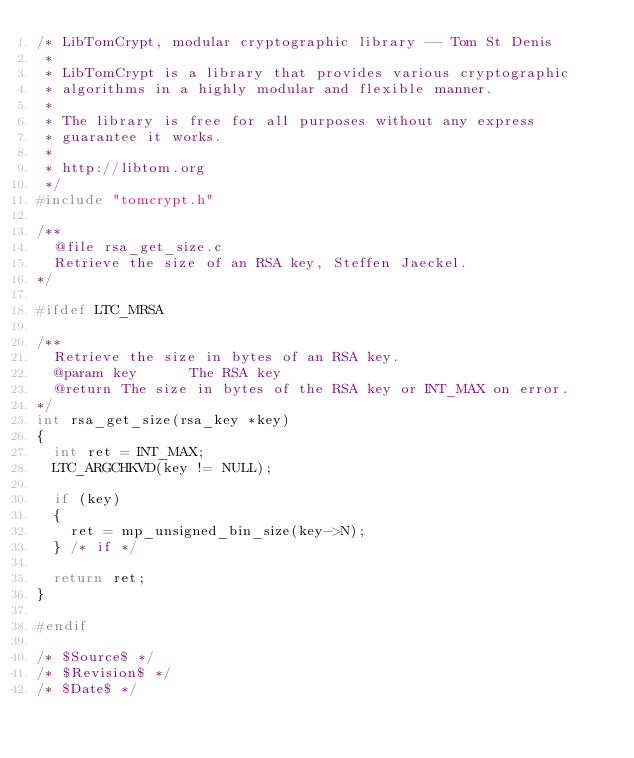Convert code to text. <code><loc_0><loc_0><loc_500><loc_500><_C_>/* LibTomCrypt, modular cryptographic library -- Tom St Denis
 *
 * LibTomCrypt is a library that provides various cryptographic
 * algorithms in a highly modular and flexible manner.
 *
 * The library is free for all purposes without any express
 * guarantee it works.
 *
 * http://libtom.org
 */
#include "tomcrypt.h"

/**
  @file rsa_get_size.c
  Retrieve the size of an RSA key, Steffen Jaeckel.
*/

#ifdef LTC_MRSA

/**
  Retrieve the size in bytes of an RSA key.
  @param key      The RSA key
  @return The size in bytes of the RSA key or INT_MAX on error.
*/
int rsa_get_size(rsa_key *key)
{
  int ret = INT_MAX;
  LTC_ARGCHKVD(key != NULL);

  if (key)
  {
    ret = mp_unsigned_bin_size(key->N);
  } /* if */

  return ret;
}

#endif

/* $Source$ */
/* $Revision$ */
/* $Date$ */
</code> 